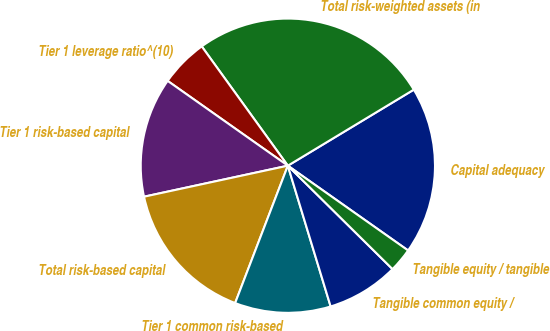Convert chart. <chart><loc_0><loc_0><loc_500><loc_500><pie_chart><fcel>Capital adequacy<fcel>Total risk-weighted assets (in<fcel>Tier 1 leverage ratio^(10)<fcel>Tier 1 risk-based capital<fcel>Total risk-based capital<fcel>Tier 1 common risk-based<fcel>Tangible common equity /<fcel>Tangible equity / tangible<nl><fcel>18.42%<fcel>26.31%<fcel>5.27%<fcel>13.16%<fcel>15.79%<fcel>10.53%<fcel>7.9%<fcel>2.63%<nl></chart> 